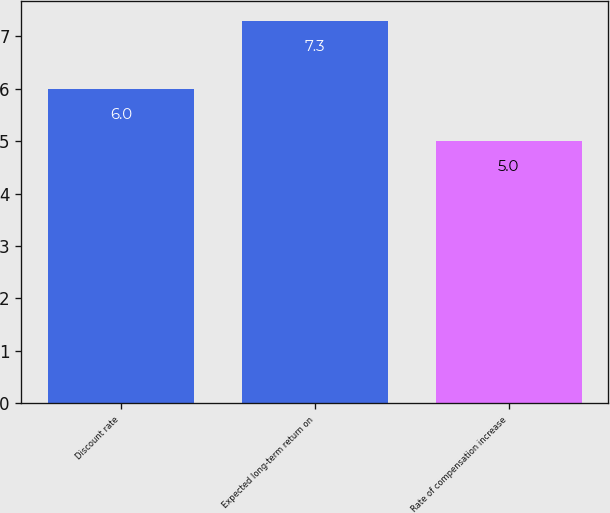Convert chart to OTSL. <chart><loc_0><loc_0><loc_500><loc_500><bar_chart><fcel>Discount rate<fcel>Expected long-term return on<fcel>Rate of compensation increase<nl><fcel>6<fcel>7.3<fcel>5<nl></chart> 